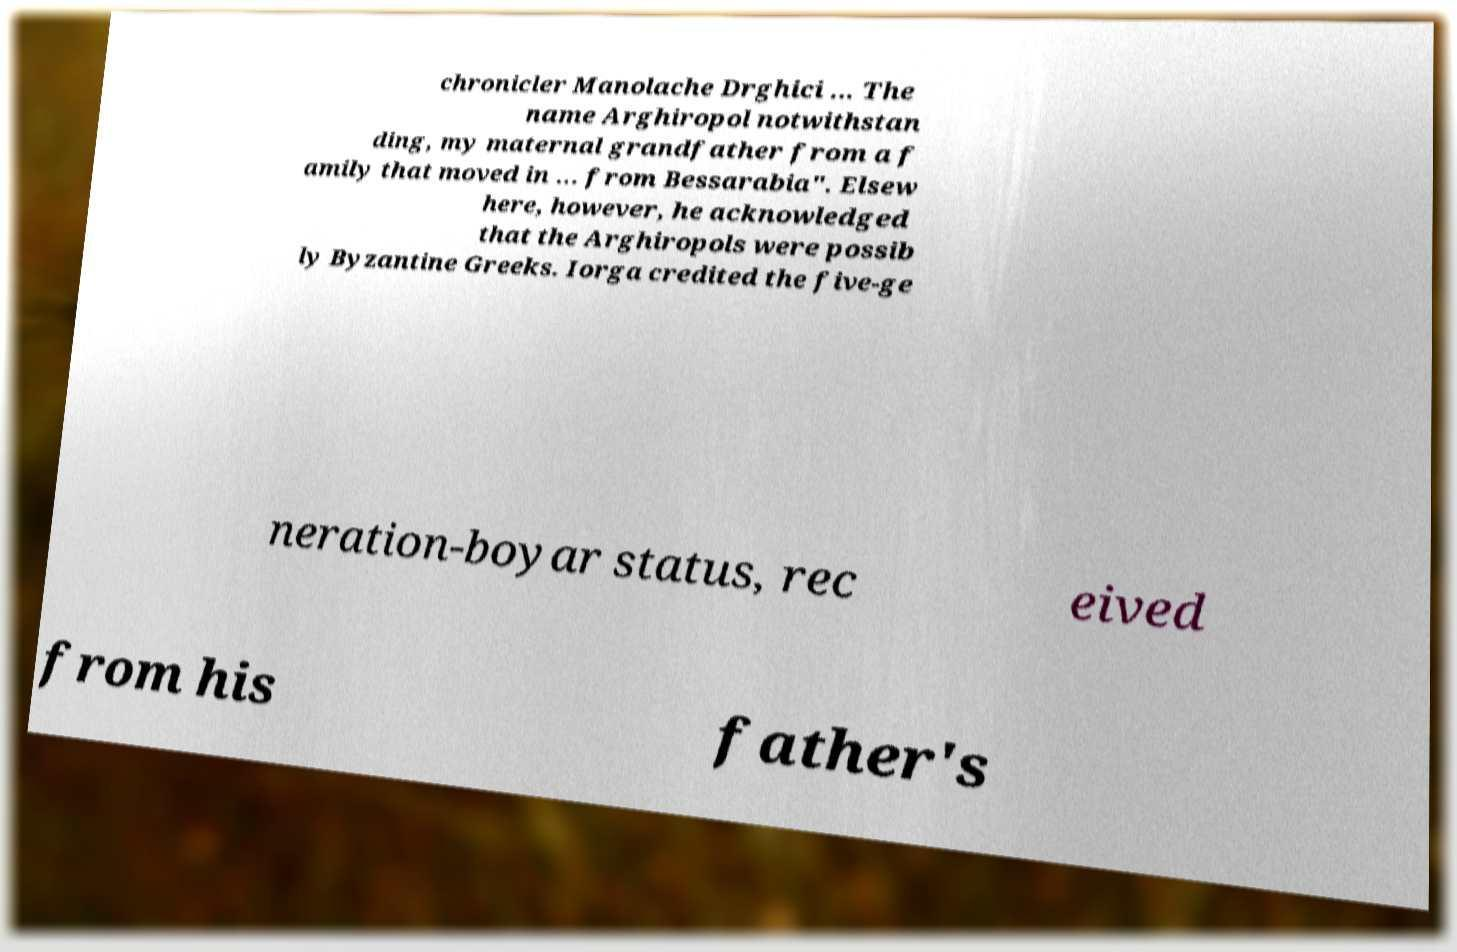Can you accurately transcribe the text from the provided image for me? chronicler Manolache Drghici ... The name Arghiropol notwithstan ding, my maternal grandfather from a f amily that moved in ... from Bessarabia". Elsew here, however, he acknowledged that the Arghiropols were possib ly Byzantine Greeks. Iorga credited the five-ge neration-boyar status, rec eived from his father's 